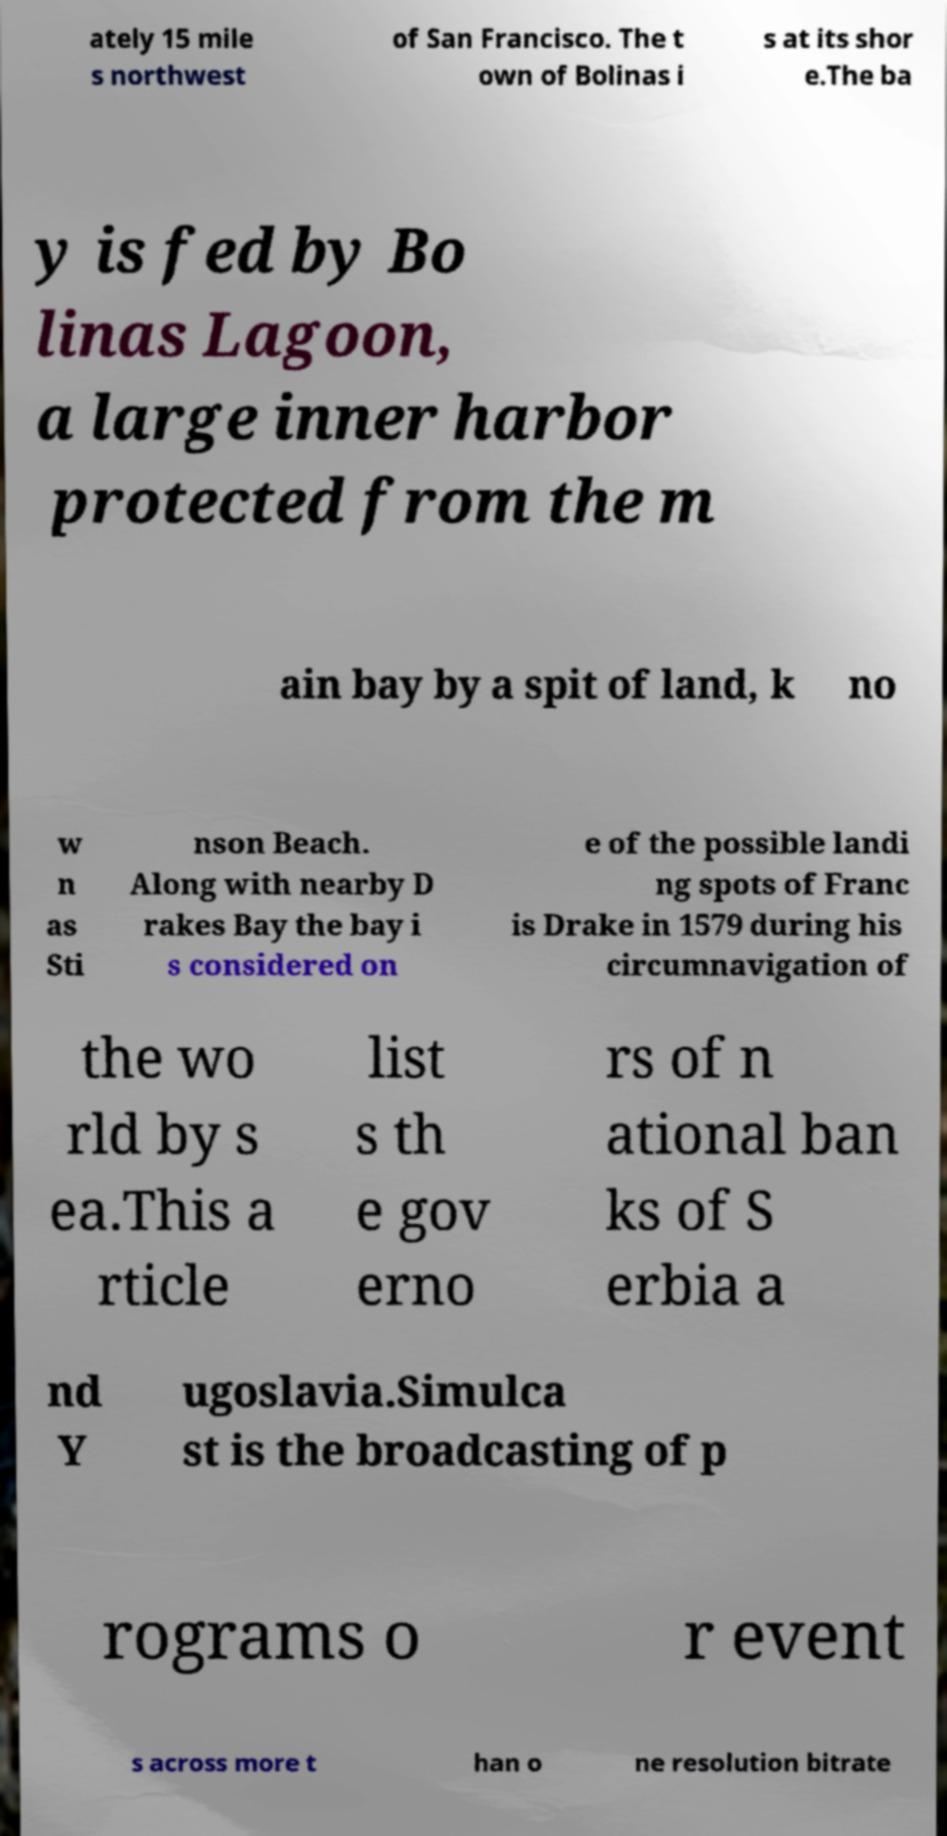For documentation purposes, I need the text within this image transcribed. Could you provide that? ately 15 mile s northwest of San Francisco. The t own of Bolinas i s at its shor e.The ba y is fed by Bo linas Lagoon, a large inner harbor protected from the m ain bay by a spit of land, k no w n as Sti nson Beach. Along with nearby D rakes Bay the bay i s considered on e of the possible landi ng spots of Franc is Drake in 1579 during his circumnavigation of the wo rld by s ea.This a rticle list s th e gov erno rs of n ational ban ks of S erbia a nd Y ugoslavia.Simulca st is the broadcasting of p rograms o r event s across more t han o ne resolution bitrate 